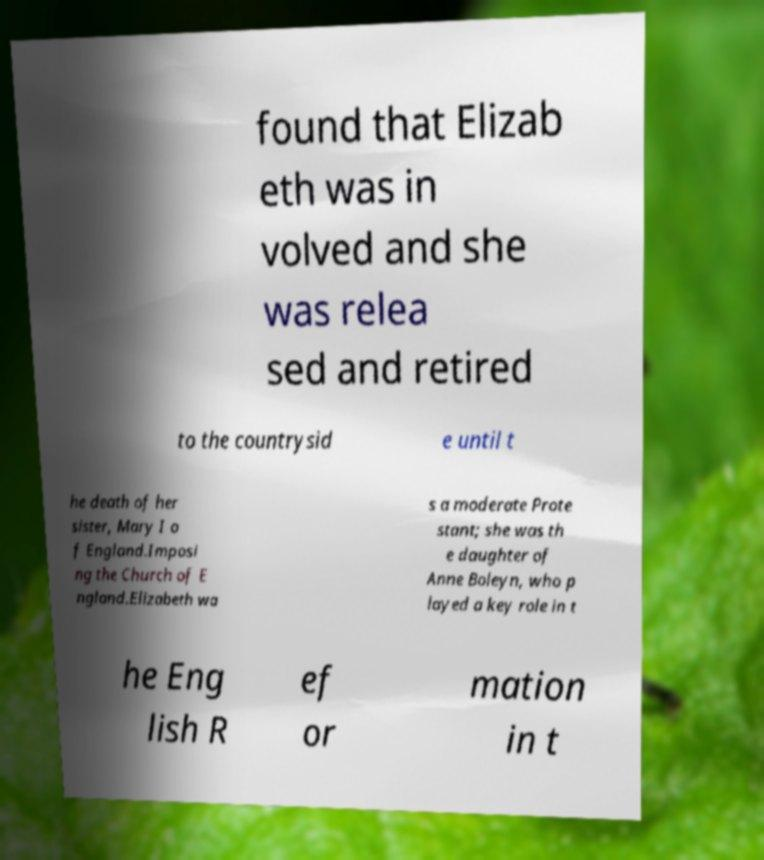There's text embedded in this image that I need extracted. Can you transcribe it verbatim? found that Elizab eth was in volved and she was relea sed and retired to the countrysid e until t he death of her sister, Mary I o f England.Imposi ng the Church of E ngland.Elizabeth wa s a moderate Prote stant; she was th e daughter of Anne Boleyn, who p layed a key role in t he Eng lish R ef or mation in t 